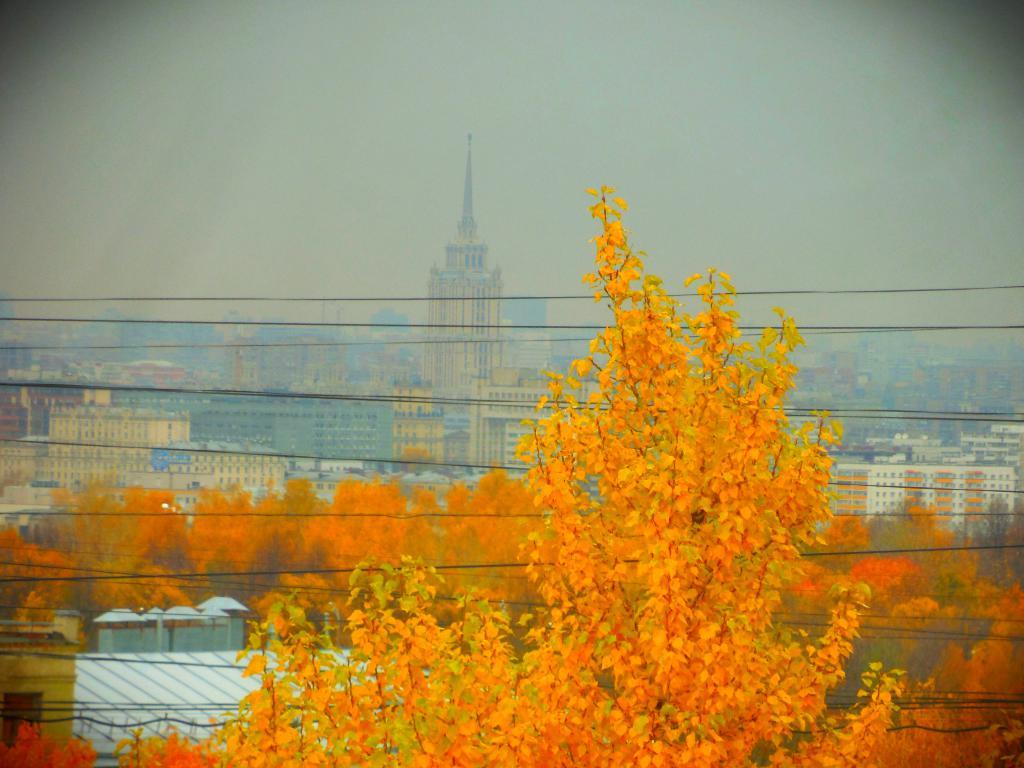What type of natural elements can be seen in the image? There are trees in the image. What type of man-made structures are present in the image? There are buildings in the image. What is the condition of the sky in the image? The sky is cloudy in the image. How many balls can be seen in the image? There are no balls present in the image. Is there a harbor visible in the image? There is no harbor present in the image. 